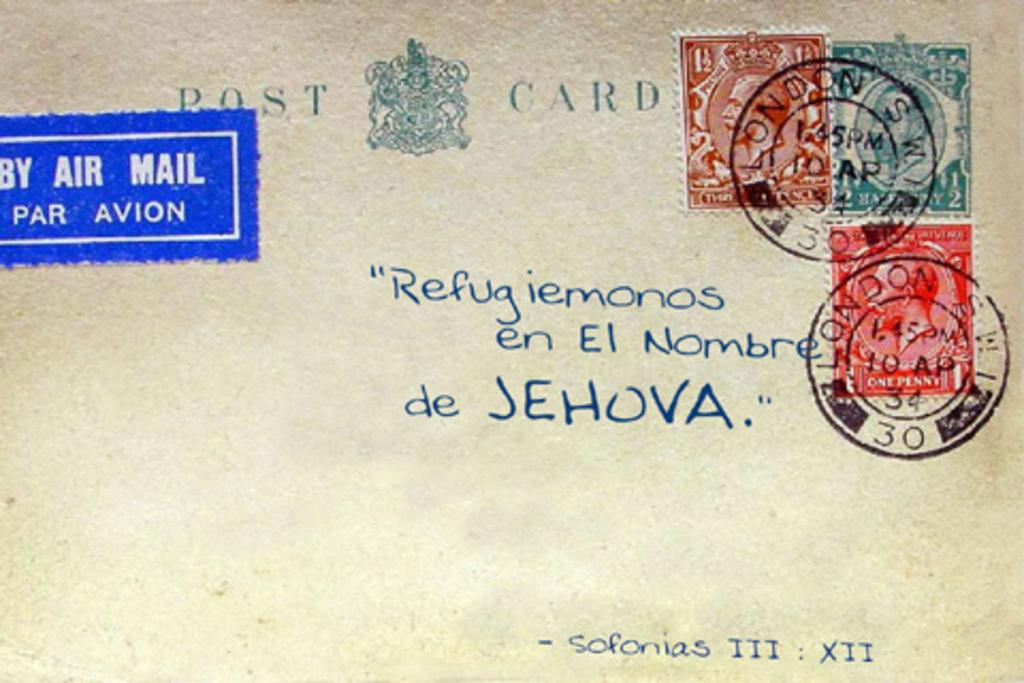Provide a one-sentence caption for the provided image. A post card with stamps from London sent by Air Mail. 